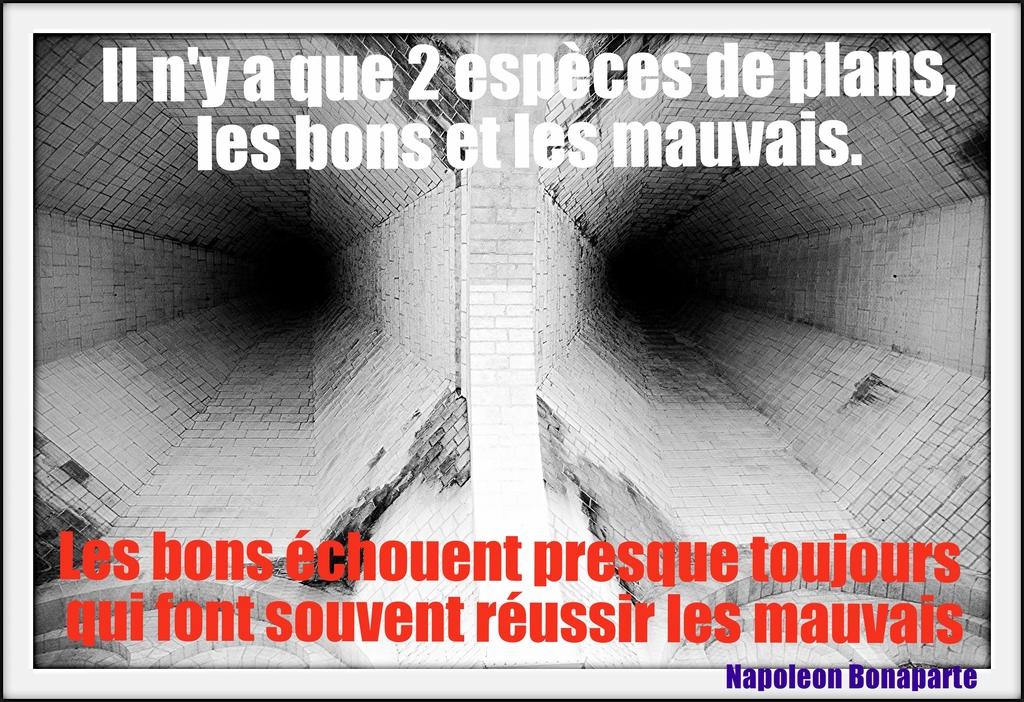Who aid this quote?
Your response must be concise. Napoleon bonaparte. What is written in the red text?
Offer a terse response. Les bons echouent presque toujours qui font souvent reussir les mauvais. 